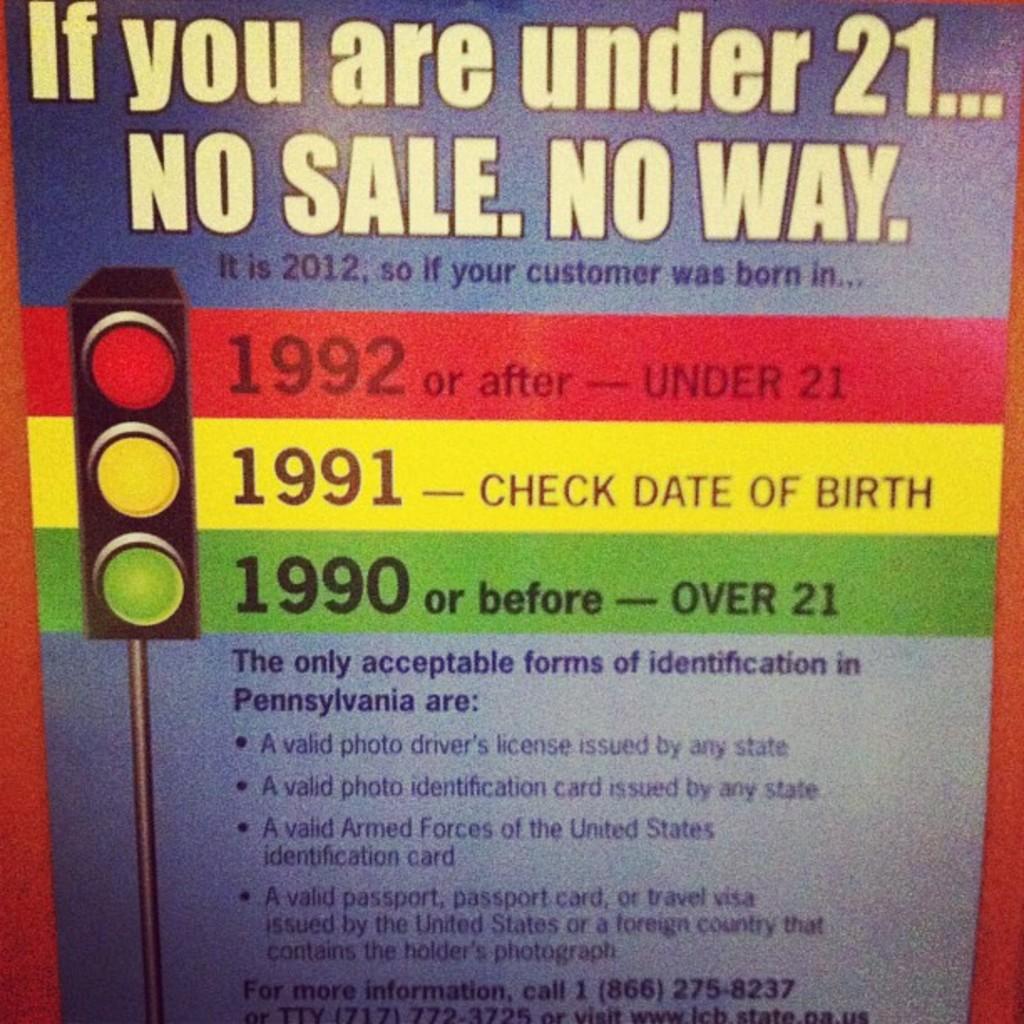What date is listed in green?
Offer a terse response. 1990. What date is listed in yellow?
Your answer should be compact. 1991. 